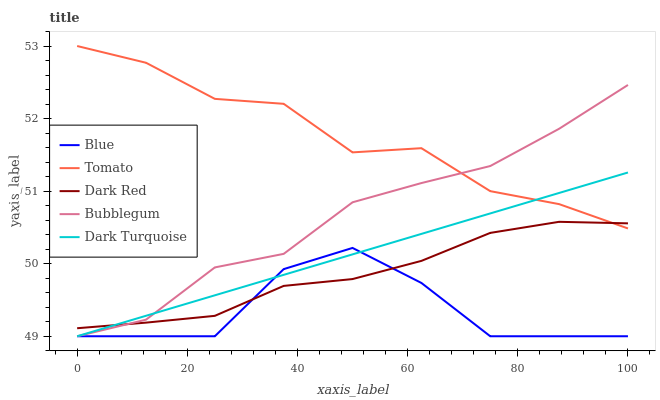Does Blue have the minimum area under the curve?
Answer yes or no. Yes. Does Dark Turquoise have the minimum area under the curve?
Answer yes or no. No. Does Dark Turquoise have the maximum area under the curve?
Answer yes or no. No. Is Blue the roughest?
Answer yes or no. Yes. Is Tomato the smoothest?
Answer yes or no. No. Is Tomato the roughest?
Answer yes or no. No. Does Tomato have the lowest value?
Answer yes or no. No. Does Dark Turquoise have the highest value?
Answer yes or no. No. Is Blue less than Tomato?
Answer yes or no. Yes. Is Tomato greater than Blue?
Answer yes or no. Yes. Does Blue intersect Tomato?
Answer yes or no. No. 